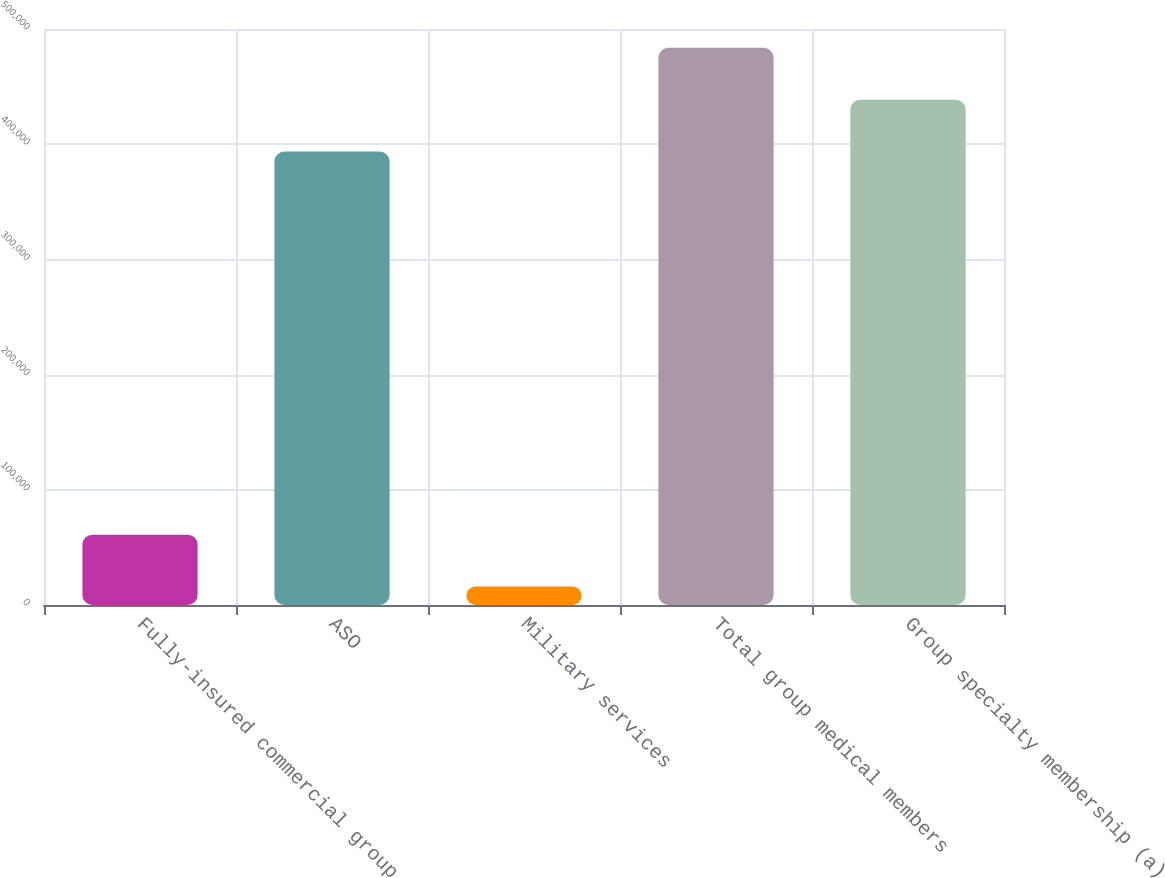Convert chart. <chart><loc_0><loc_0><loc_500><loc_500><bar_chart><fcel>Fully-insured commercial group<fcel>ASO<fcel>Military services<fcel>Total group medical members<fcel>Group specialty membership (a)<nl><fcel>61080<fcel>393600<fcel>16000<fcel>483760<fcel>438680<nl></chart> 